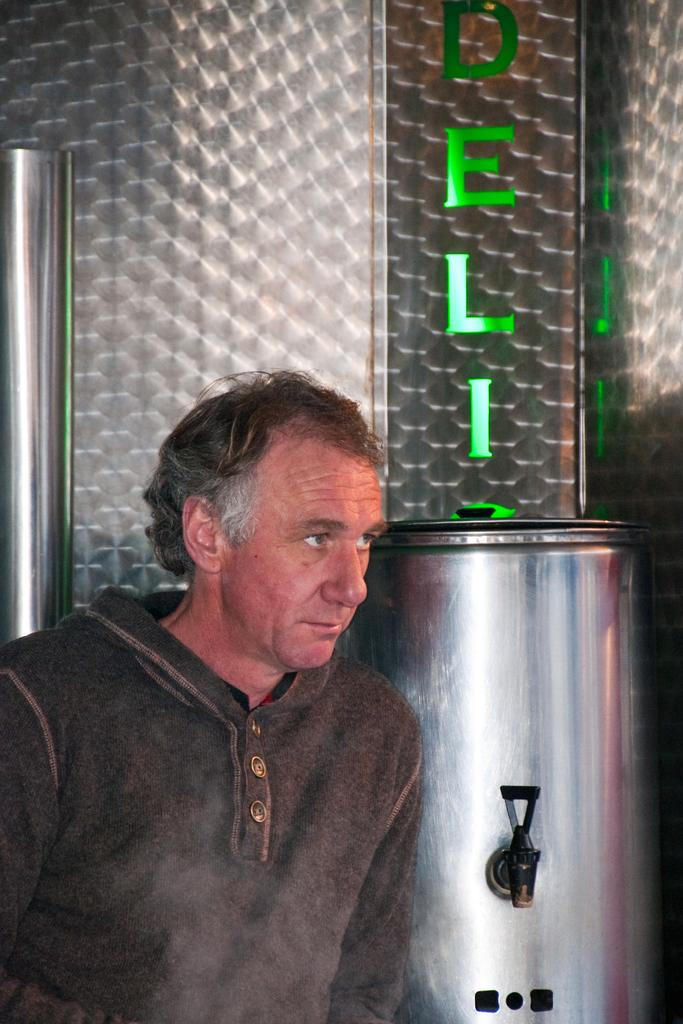Who is present in the image? There is a man in the image. What is the man wearing? The man is wearing clothes. What type of object can be seen in the image made of metal? There is a metal container and a metal wall in the image. What kind of text is visible in the image? There is LED text in the image. What type of juice is being served in the image? There is no juice present in the image. How many people are visible in the image? The image only shows one person, the man. 